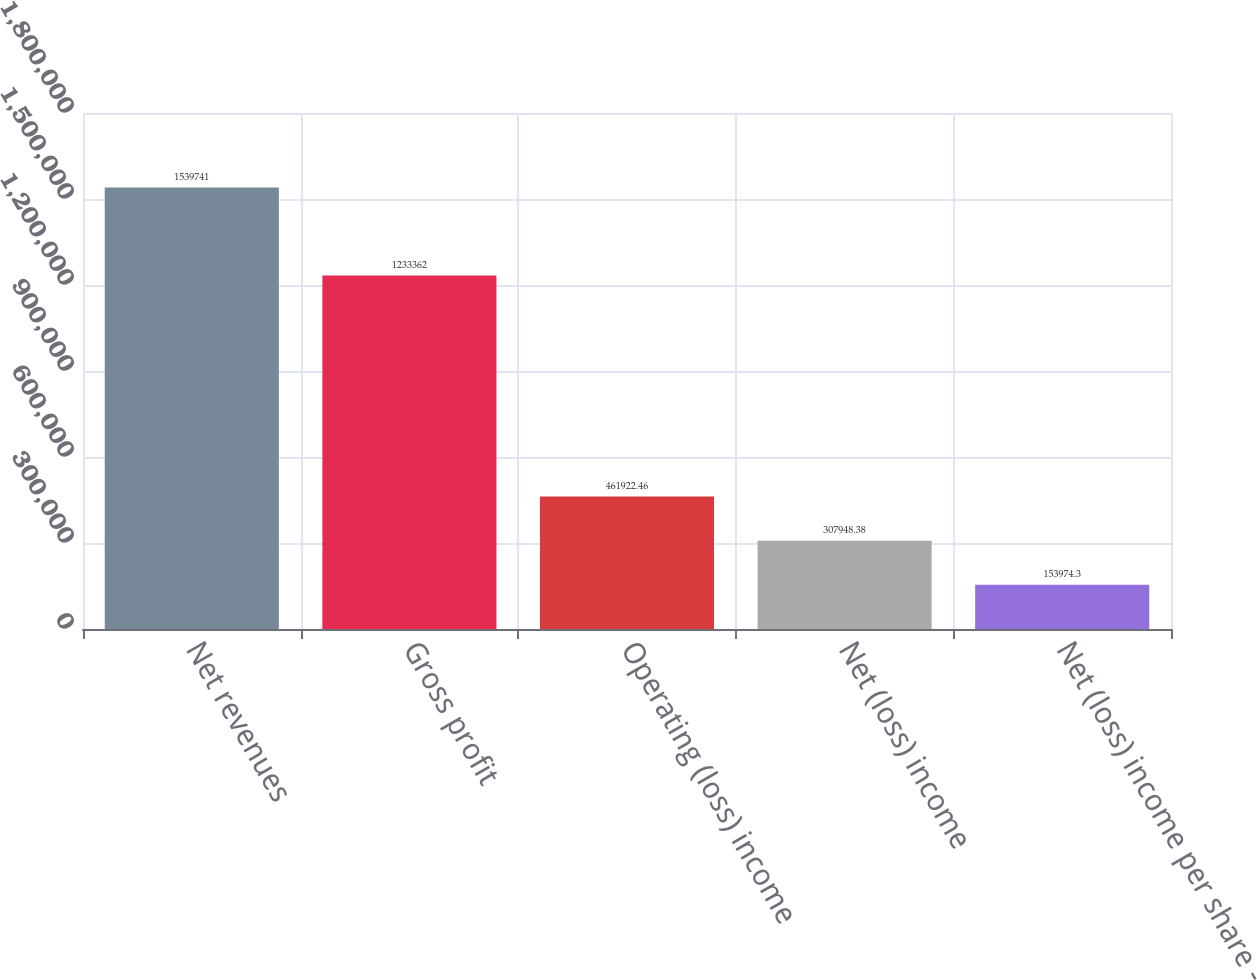<chart> <loc_0><loc_0><loc_500><loc_500><bar_chart><fcel>Net revenues<fcel>Gross profit<fcel>Operating (loss) income<fcel>Net (loss) income<fcel>Net (loss) income per share -<nl><fcel>1.53974e+06<fcel>1.23336e+06<fcel>461922<fcel>307948<fcel>153974<nl></chart> 